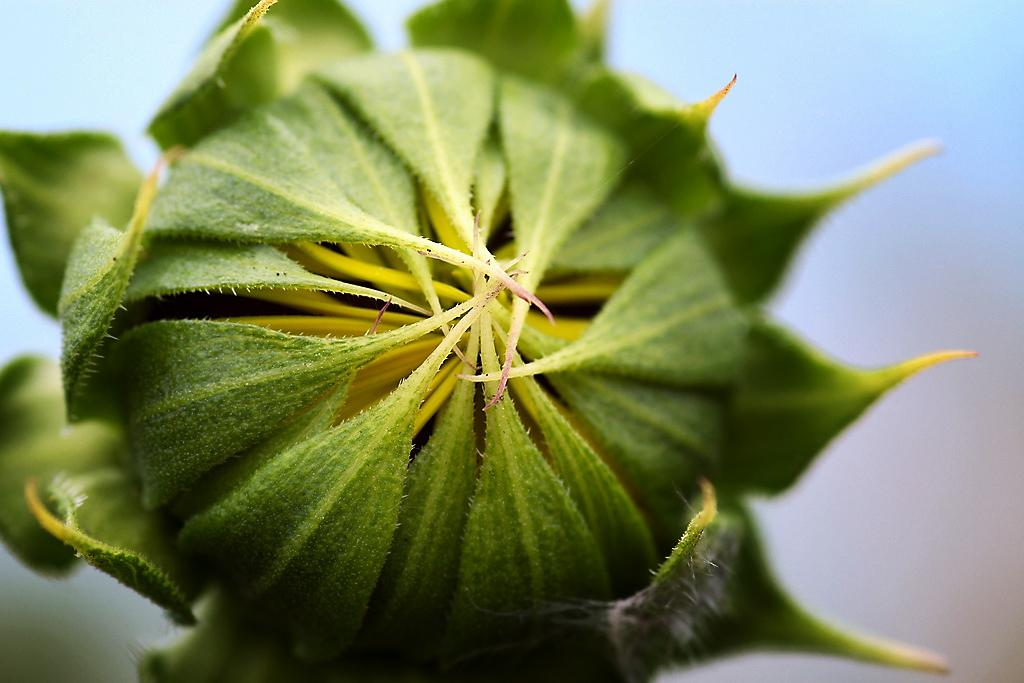What is the main subject of the image? The main subject of the image is a flower bud. Can you describe the color of the flower bud? The flower bud is green in color. What type of soup is being exchanged in the image? There is no soup or exchange present in the image; it features a green flower bud. 